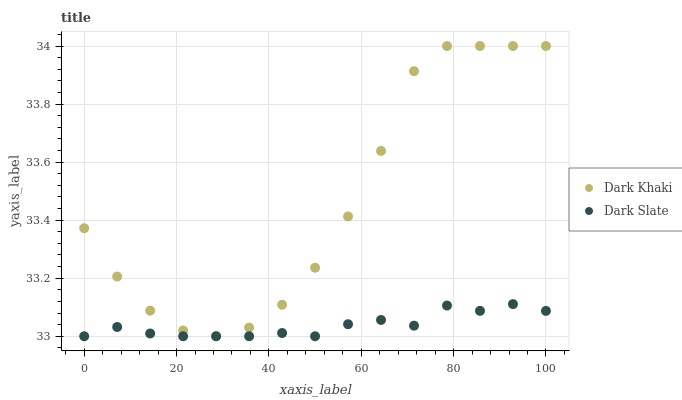Does Dark Slate have the minimum area under the curve?
Answer yes or no. Yes. Does Dark Khaki have the maximum area under the curve?
Answer yes or no. Yes. Does Dark Slate have the maximum area under the curve?
Answer yes or no. No. Is Dark Slate the smoothest?
Answer yes or no. Yes. Is Dark Khaki the roughest?
Answer yes or no. Yes. Is Dark Slate the roughest?
Answer yes or no. No. Does Dark Slate have the lowest value?
Answer yes or no. Yes. Does Dark Khaki have the highest value?
Answer yes or no. Yes. Does Dark Slate have the highest value?
Answer yes or no. No. Is Dark Slate less than Dark Khaki?
Answer yes or no. Yes. Is Dark Khaki greater than Dark Slate?
Answer yes or no. Yes. Does Dark Slate intersect Dark Khaki?
Answer yes or no. No. 